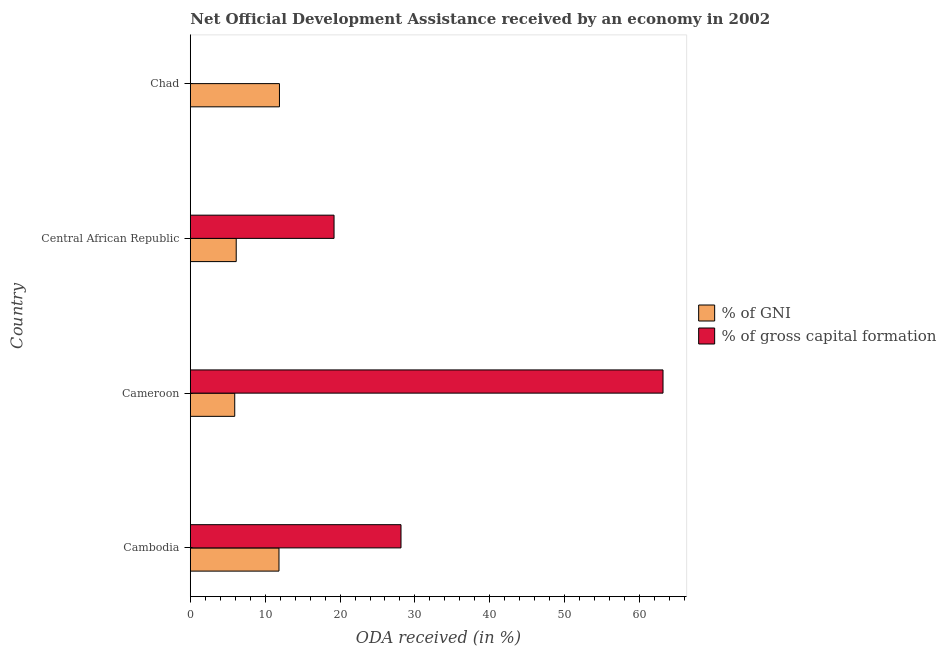What is the label of the 4th group of bars from the top?
Provide a short and direct response. Cambodia. In how many cases, is the number of bars for a given country not equal to the number of legend labels?
Make the answer very short. 1. What is the oda received as percentage of gross capital formation in Cameroon?
Make the answer very short. 63.13. Across all countries, what is the maximum oda received as percentage of gni?
Give a very brief answer. 11.91. Across all countries, what is the minimum oda received as percentage of gni?
Offer a terse response. 5.94. In which country was the oda received as percentage of gni maximum?
Keep it short and to the point. Chad. What is the total oda received as percentage of gross capital formation in the graph?
Provide a succinct answer. 110.47. What is the difference between the oda received as percentage of gni in Cameroon and that in Central African Republic?
Offer a very short reply. -0.2. What is the difference between the oda received as percentage of gni in Cameroon and the oda received as percentage of gross capital formation in Cambodia?
Ensure brevity in your answer.  -22.2. What is the average oda received as percentage of gross capital formation per country?
Give a very brief answer. 27.62. What is the difference between the oda received as percentage of gross capital formation and oda received as percentage of gni in Central African Republic?
Make the answer very short. 13.06. In how many countries, is the oda received as percentage of gross capital formation greater than 26 %?
Your answer should be compact. 2. What is the ratio of the oda received as percentage of gross capital formation in Cameroon to that in Central African Republic?
Provide a succinct answer. 3.29. Is the oda received as percentage of gni in Cambodia less than that in Central African Republic?
Give a very brief answer. No. What is the difference between the highest and the second highest oda received as percentage of gross capital formation?
Offer a terse response. 34.99. What is the difference between the highest and the lowest oda received as percentage of gross capital formation?
Give a very brief answer. 63.13. Are all the bars in the graph horizontal?
Make the answer very short. Yes. How many legend labels are there?
Provide a succinct answer. 2. How are the legend labels stacked?
Your response must be concise. Vertical. What is the title of the graph?
Offer a terse response. Net Official Development Assistance received by an economy in 2002. What is the label or title of the X-axis?
Keep it short and to the point. ODA received (in %). What is the ODA received (in %) of % of GNI in Cambodia?
Give a very brief answer. 11.85. What is the ODA received (in %) of % of gross capital formation in Cambodia?
Your answer should be compact. 28.14. What is the ODA received (in %) in % of GNI in Cameroon?
Your response must be concise. 5.94. What is the ODA received (in %) in % of gross capital formation in Cameroon?
Ensure brevity in your answer.  63.13. What is the ODA received (in %) of % of GNI in Central African Republic?
Give a very brief answer. 6.13. What is the ODA received (in %) of % of gross capital formation in Central African Republic?
Your answer should be very brief. 19.2. What is the ODA received (in %) in % of GNI in Chad?
Provide a short and direct response. 11.91. Across all countries, what is the maximum ODA received (in %) of % of GNI?
Provide a short and direct response. 11.91. Across all countries, what is the maximum ODA received (in %) of % of gross capital formation?
Make the answer very short. 63.13. Across all countries, what is the minimum ODA received (in %) of % of GNI?
Offer a very short reply. 5.94. What is the total ODA received (in %) of % of GNI in the graph?
Ensure brevity in your answer.  35.82. What is the total ODA received (in %) in % of gross capital formation in the graph?
Give a very brief answer. 110.47. What is the difference between the ODA received (in %) in % of GNI in Cambodia and that in Cameroon?
Provide a succinct answer. 5.91. What is the difference between the ODA received (in %) of % of gross capital formation in Cambodia and that in Cameroon?
Your answer should be very brief. -34.99. What is the difference between the ODA received (in %) in % of GNI in Cambodia and that in Central African Republic?
Offer a very short reply. 5.71. What is the difference between the ODA received (in %) in % of gross capital formation in Cambodia and that in Central African Republic?
Offer a very short reply. 8.94. What is the difference between the ODA received (in %) in % of GNI in Cambodia and that in Chad?
Provide a short and direct response. -0.06. What is the difference between the ODA received (in %) of % of GNI in Cameroon and that in Central African Republic?
Your response must be concise. -0.2. What is the difference between the ODA received (in %) in % of gross capital formation in Cameroon and that in Central African Republic?
Provide a short and direct response. 43.93. What is the difference between the ODA received (in %) of % of GNI in Cameroon and that in Chad?
Provide a short and direct response. -5.97. What is the difference between the ODA received (in %) of % of GNI in Central African Republic and that in Chad?
Offer a very short reply. -5.77. What is the difference between the ODA received (in %) in % of GNI in Cambodia and the ODA received (in %) in % of gross capital formation in Cameroon?
Make the answer very short. -51.29. What is the difference between the ODA received (in %) of % of GNI in Cambodia and the ODA received (in %) of % of gross capital formation in Central African Republic?
Offer a terse response. -7.35. What is the difference between the ODA received (in %) in % of GNI in Cameroon and the ODA received (in %) in % of gross capital formation in Central African Republic?
Offer a terse response. -13.26. What is the average ODA received (in %) of % of GNI per country?
Provide a short and direct response. 8.96. What is the average ODA received (in %) of % of gross capital formation per country?
Your response must be concise. 27.62. What is the difference between the ODA received (in %) in % of GNI and ODA received (in %) in % of gross capital formation in Cambodia?
Keep it short and to the point. -16.29. What is the difference between the ODA received (in %) in % of GNI and ODA received (in %) in % of gross capital formation in Cameroon?
Offer a very short reply. -57.2. What is the difference between the ODA received (in %) in % of GNI and ODA received (in %) in % of gross capital formation in Central African Republic?
Offer a terse response. -13.06. What is the ratio of the ODA received (in %) of % of GNI in Cambodia to that in Cameroon?
Your answer should be very brief. 2. What is the ratio of the ODA received (in %) in % of gross capital formation in Cambodia to that in Cameroon?
Provide a short and direct response. 0.45. What is the ratio of the ODA received (in %) in % of GNI in Cambodia to that in Central African Republic?
Offer a very short reply. 1.93. What is the ratio of the ODA received (in %) in % of gross capital formation in Cambodia to that in Central African Republic?
Your answer should be compact. 1.47. What is the ratio of the ODA received (in %) in % of GNI in Cambodia to that in Chad?
Provide a succinct answer. 0.99. What is the ratio of the ODA received (in %) of % of GNI in Cameroon to that in Central African Republic?
Ensure brevity in your answer.  0.97. What is the ratio of the ODA received (in %) of % of gross capital formation in Cameroon to that in Central African Republic?
Give a very brief answer. 3.29. What is the ratio of the ODA received (in %) in % of GNI in Cameroon to that in Chad?
Give a very brief answer. 0.5. What is the ratio of the ODA received (in %) in % of GNI in Central African Republic to that in Chad?
Keep it short and to the point. 0.52. What is the difference between the highest and the second highest ODA received (in %) of % of GNI?
Your response must be concise. 0.06. What is the difference between the highest and the second highest ODA received (in %) in % of gross capital formation?
Offer a very short reply. 34.99. What is the difference between the highest and the lowest ODA received (in %) of % of GNI?
Provide a short and direct response. 5.97. What is the difference between the highest and the lowest ODA received (in %) in % of gross capital formation?
Make the answer very short. 63.13. 